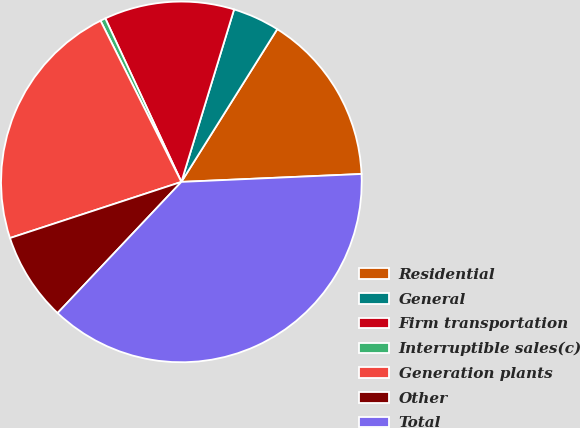Convert chart. <chart><loc_0><loc_0><loc_500><loc_500><pie_chart><fcel>Residential<fcel>General<fcel>Firm transportation<fcel>Interruptible sales(c)<fcel>Generation plants<fcel>Other<fcel>Total<nl><fcel>15.38%<fcel>4.2%<fcel>11.65%<fcel>0.47%<fcel>22.64%<fcel>7.92%<fcel>37.74%<nl></chart> 